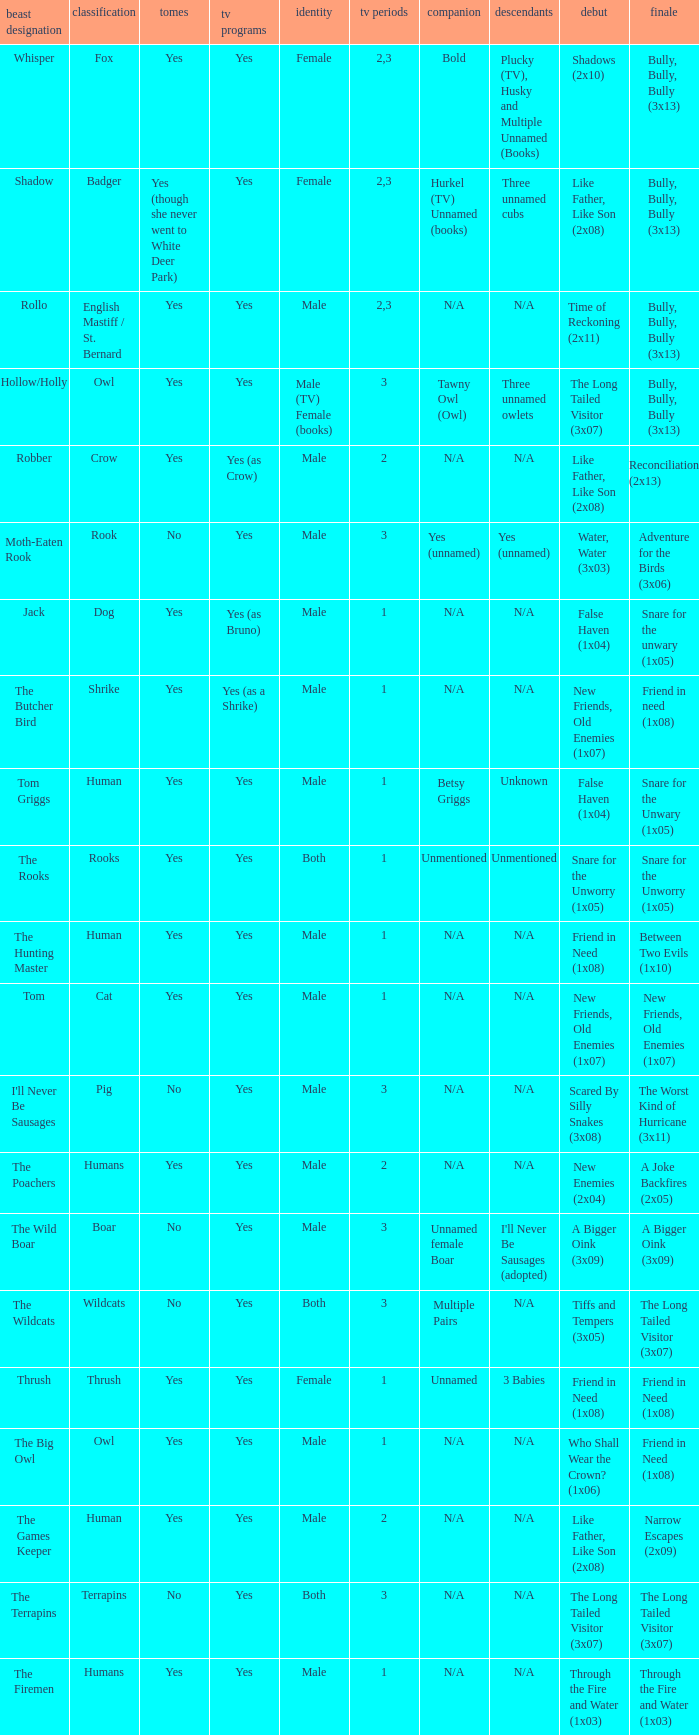What animal was yes for tv series and was a terrapins? The Terrapins. 